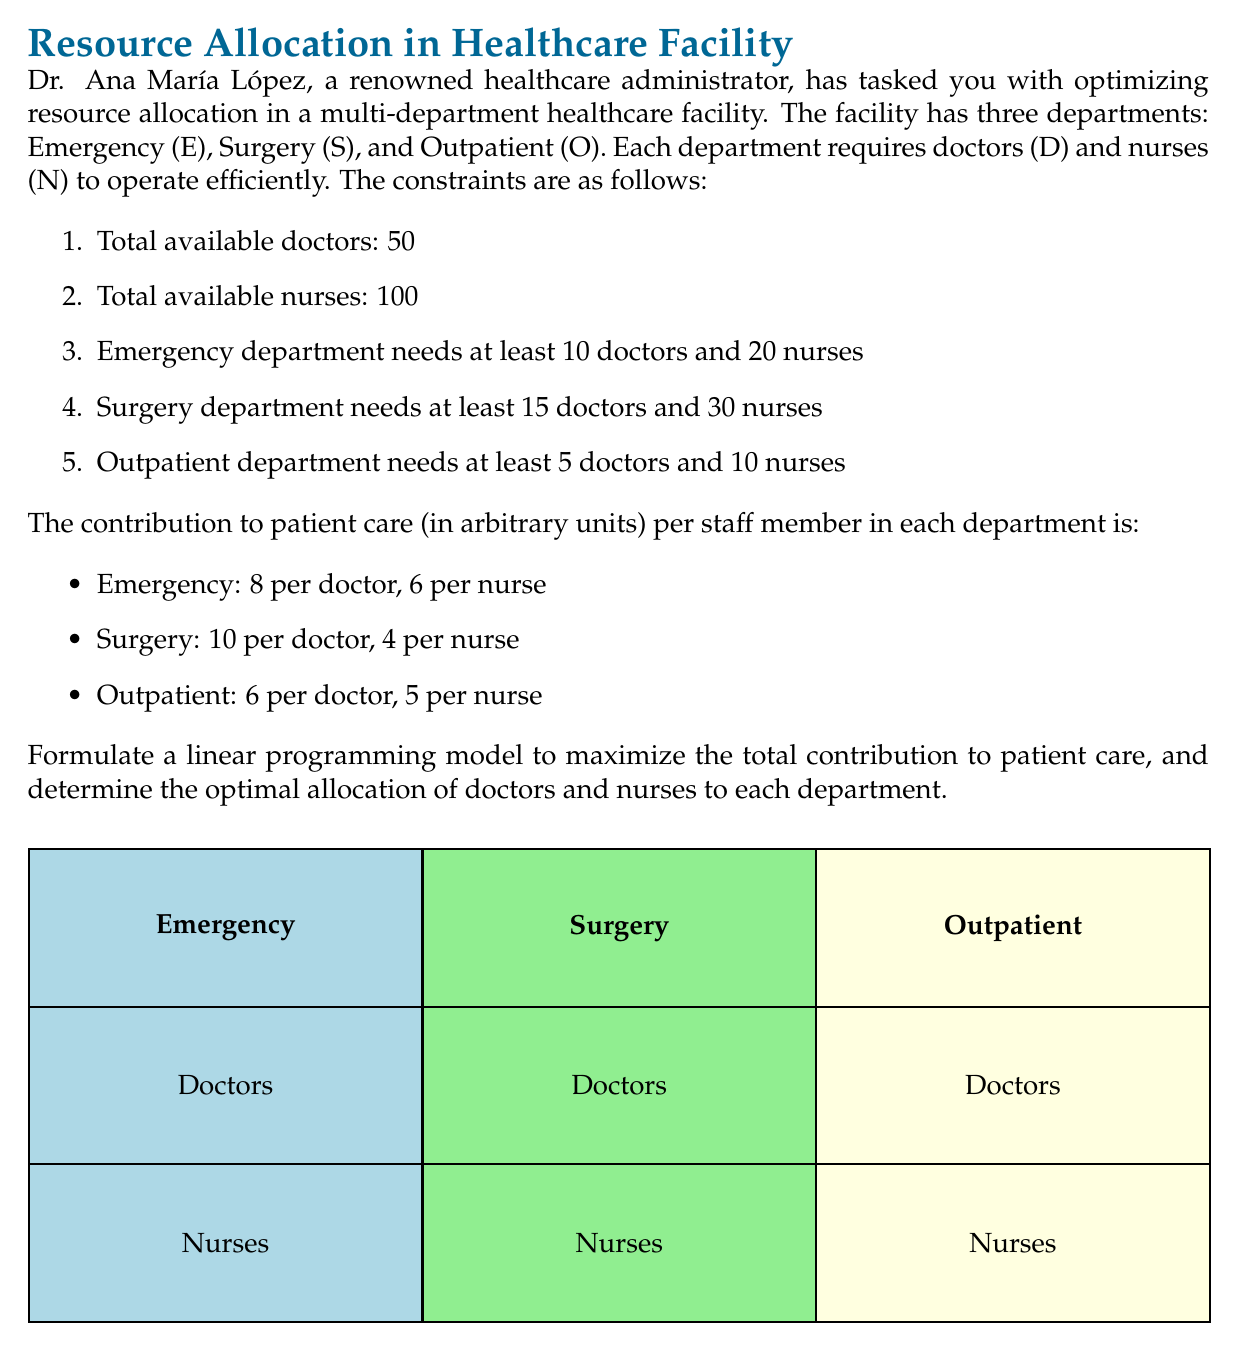Teach me how to tackle this problem. Let's approach this step-by-step:

1) Define variables:
   $D_E$, $D_S$, $D_O$: Number of doctors in Emergency, Surgery, and Outpatient departments
   $N_E$, $N_S$, $N_O$: Number of nurses in Emergency, Surgery, and Outpatient departments

2) Objective function:
   Maximize $Z = 8D_E + 6N_E + 10D_S + 4N_S + 6D_O + 5N_O$

3) Constraints:
   a) Total doctors: $D_E + D_S + D_O \leq 50$
   b) Total nurses: $N_E + N_S + N_O \leq 100$
   c) Emergency department: $D_E \geq 10$, $N_E \geq 20$
   d) Surgery department: $D_S \geq 15$, $N_S \geq 30$
   e) Outpatient department: $D_O \geq 5$, $N_O \geq 10$
   f) Non-negativity: All variables $\geq 0$

4) To solve this, we can use the simplex method or a linear programming solver. However, we can make some observations:

   - The surgery department has the highest contribution per doctor (10), so we should allocate as many doctors there as possible.
   - The emergency department has the next highest contribution per doctor (8) and the highest per nurse (6).
   - The outpatient department has the lowest contribution per doctor but second-highest per nurse.

5) Optimal allocation:
   - Surgery: 15 doctors (minimum required), 30 nurses (minimum required)
   - Emergency: 30 doctors (remaining after surgery), 60 nurses (remaining after surgery)
   - Outpatient: 5 doctors (minimum required), 10 nurses (minimum required)

6) Verification:
   - Total doctors: 15 + 30 + 5 = 50
   - Total nurses: 30 + 60 + 10 = 100
   - All department minimums are met

7) Calculate total contribution:
   $Z = (8 * 30 + 6 * 60) + (10 * 15 + 4 * 30) + (6 * 5 + 5 * 10) = 240 + 360 + 150 + 120 + 30 + 50 = 950$
Answer: Optimal allocation: Surgery (15D, 30N), Emergency (30D, 60N), Outpatient (5D, 10N). Maximum contribution: 950 units. 